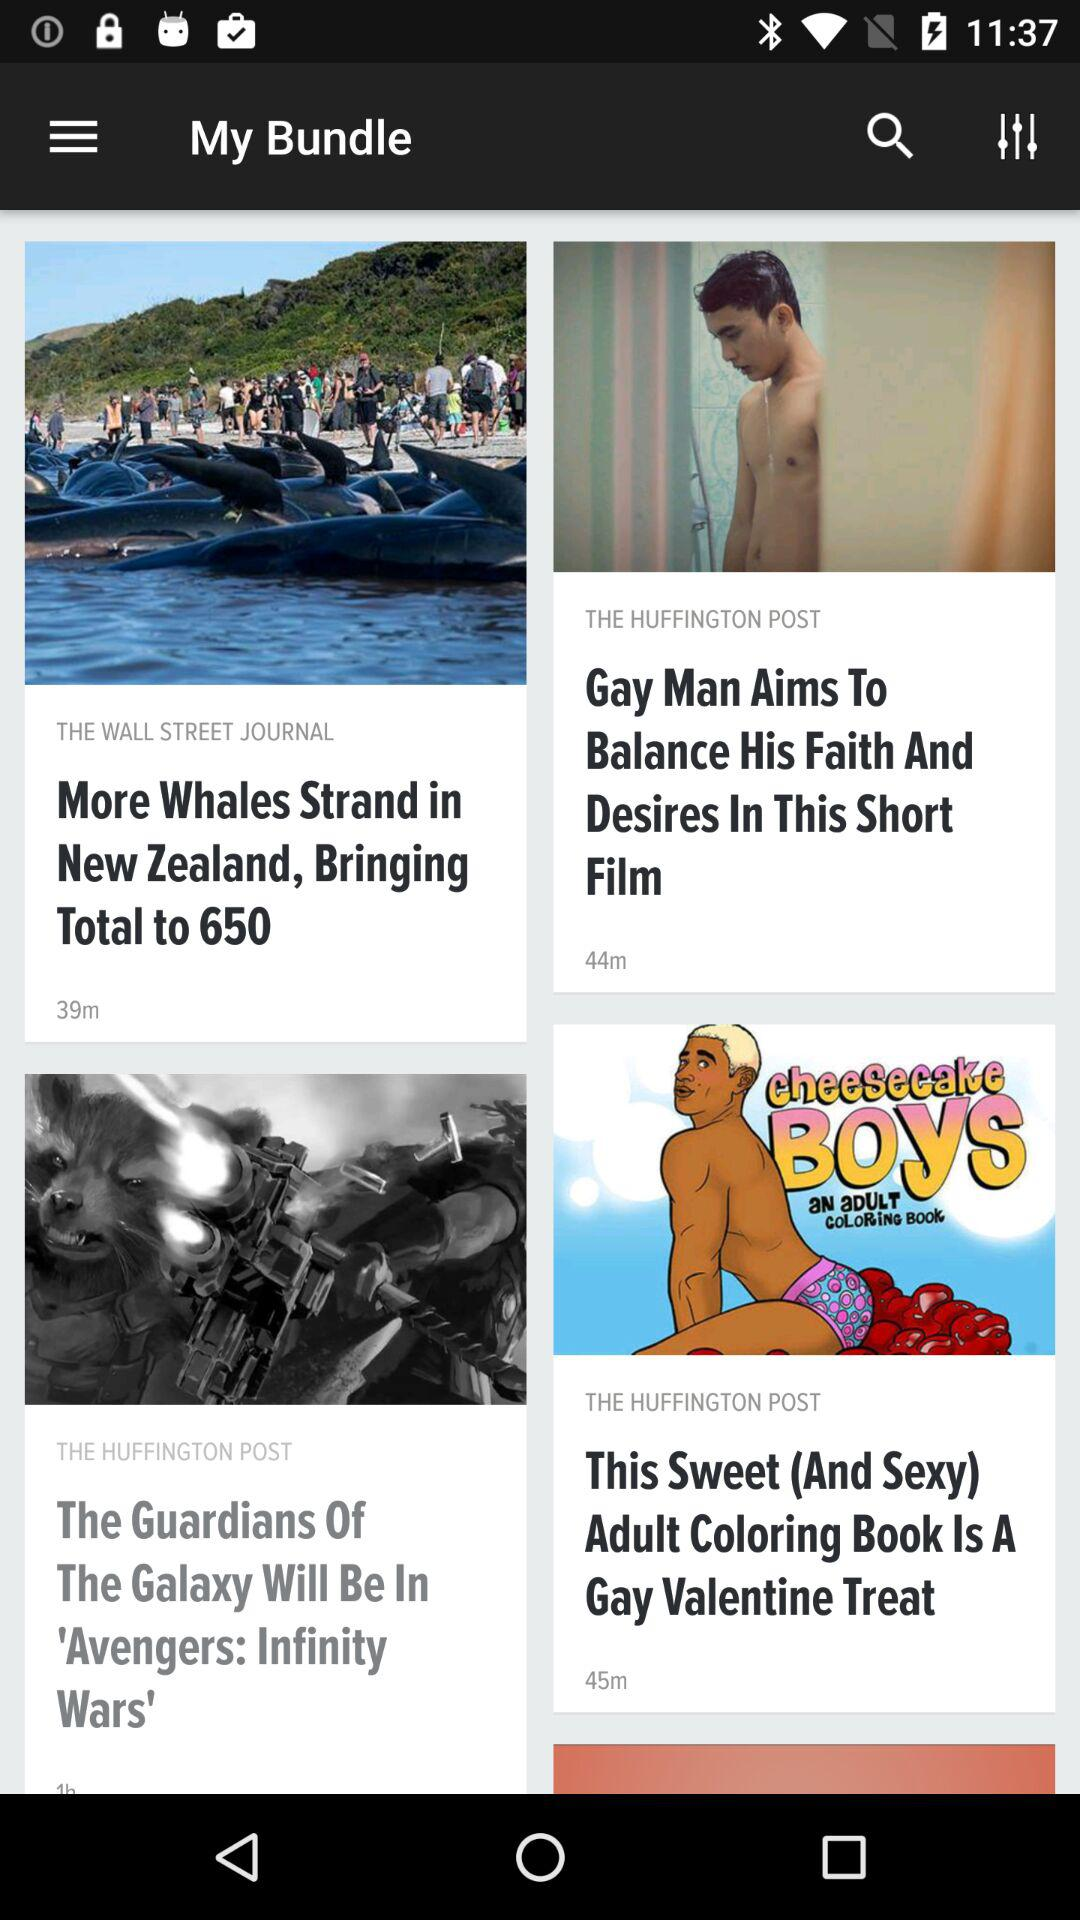How many minutes ago was the article by "THE WALL STREET JOURNAL" posted? The article was posted 39 minutes ago. 